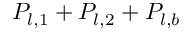Convert formula to latex. <formula><loc_0><loc_0><loc_500><loc_500>P _ { l , 1 } + P _ { l , 2 } + P _ { l , b }</formula> 